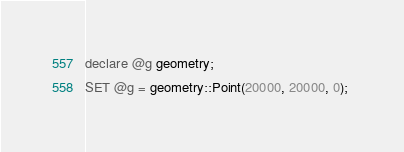<code> <loc_0><loc_0><loc_500><loc_500><_SQL_>declare @g geometry;
SET @g = geometry::Point(20000, 20000, 0); </code> 